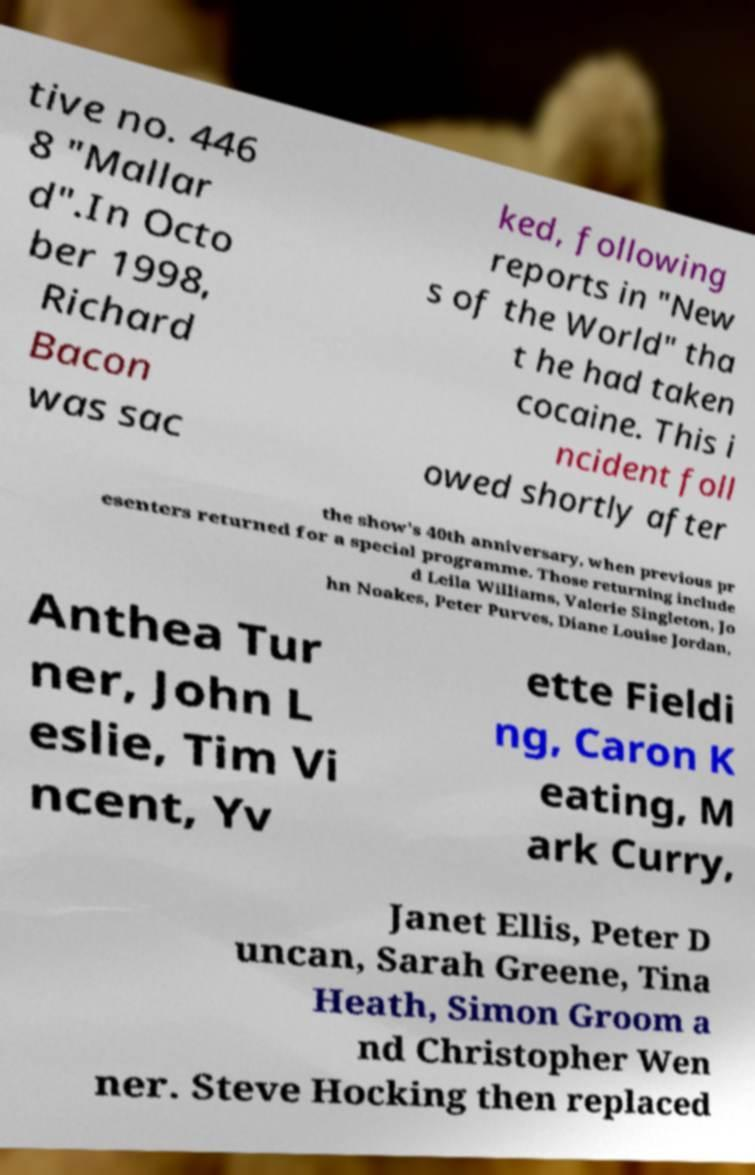I need the written content from this picture converted into text. Can you do that? tive no. 446 8 "Mallar d".In Octo ber 1998, Richard Bacon was sac ked, following reports in "New s of the World" tha t he had taken cocaine. This i ncident foll owed shortly after the show's 40th anniversary, when previous pr esenters returned for a special programme. Those returning include d Leila Williams, Valerie Singleton, Jo hn Noakes, Peter Purves, Diane Louise Jordan, Anthea Tur ner, John L eslie, Tim Vi ncent, Yv ette Fieldi ng, Caron K eating, M ark Curry, Janet Ellis, Peter D uncan, Sarah Greene, Tina Heath, Simon Groom a nd Christopher Wen ner. Steve Hocking then replaced 